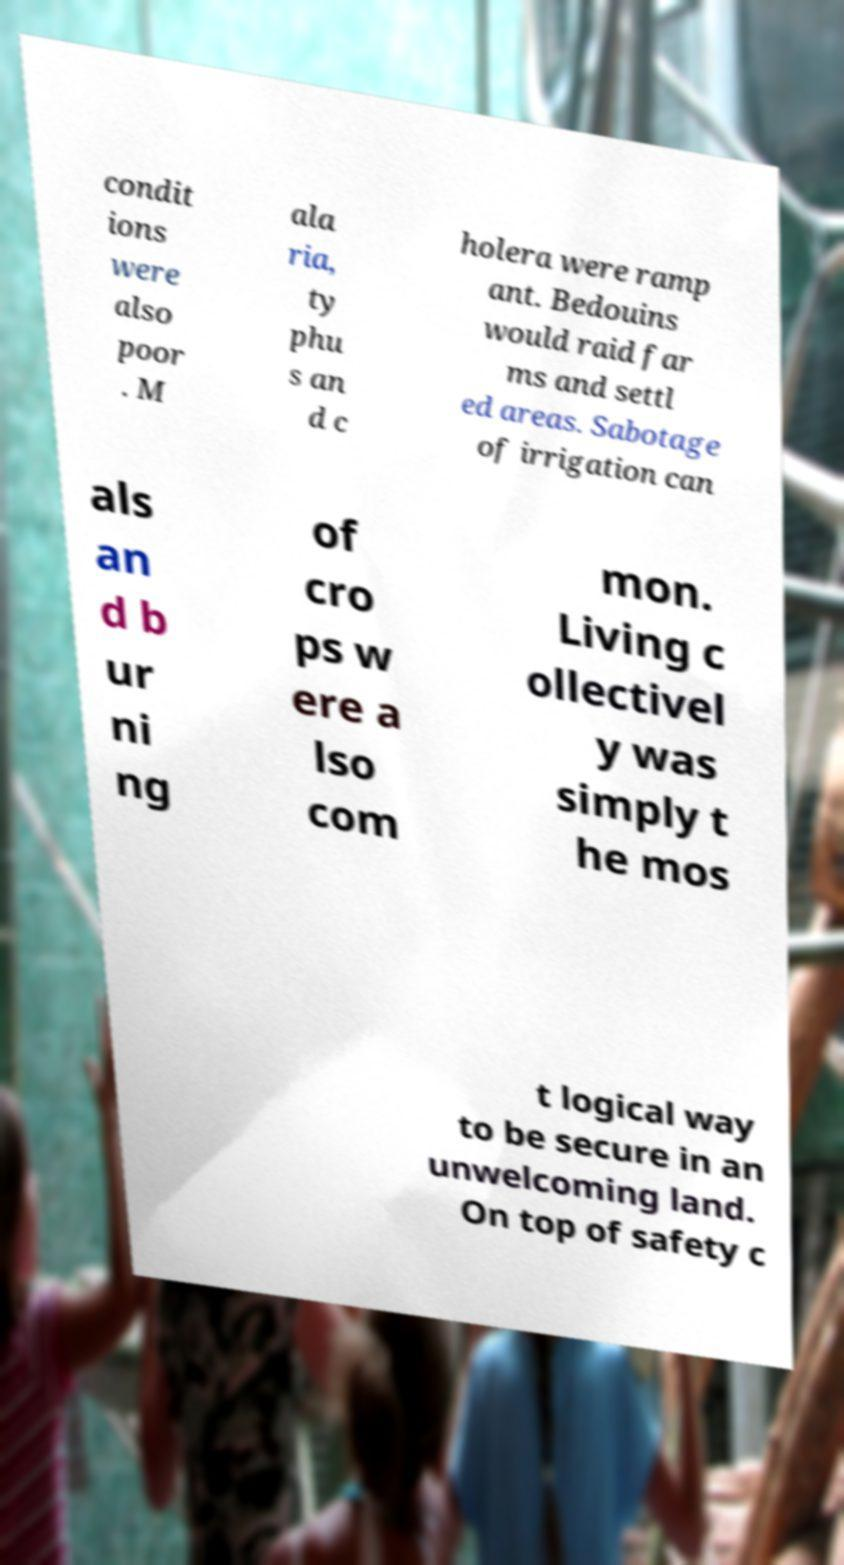Can you read and provide the text displayed in the image?This photo seems to have some interesting text. Can you extract and type it out for me? condit ions were also poor . M ala ria, ty phu s an d c holera were ramp ant. Bedouins would raid far ms and settl ed areas. Sabotage of irrigation can als an d b ur ni ng of cro ps w ere a lso com mon. Living c ollectivel y was simply t he mos t logical way to be secure in an unwelcoming land. On top of safety c 